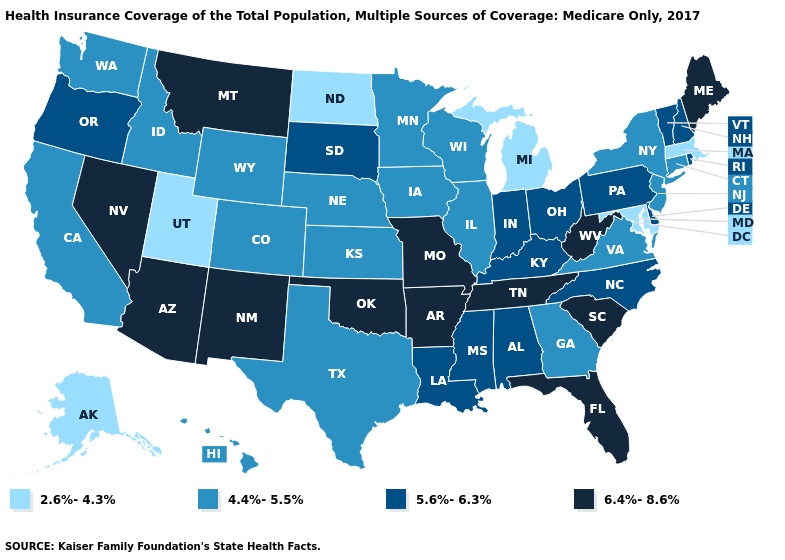What is the value of Arkansas?
Write a very short answer. 6.4%-8.6%. Among the states that border Ohio , which have the highest value?
Keep it brief. West Virginia. Does New York have a higher value than Michigan?
Be succinct. Yes. Which states hav the highest value in the MidWest?
Write a very short answer. Missouri. Among the states that border Florida , which have the lowest value?
Short answer required. Georgia. Name the states that have a value in the range 4.4%-5.5%?
Keep it brief. California, Colorado, Connecticut, Georgia, Hawaii, Idaho, Illinois, Iowa, Kansas, Minnesota, Nebraska, New Jersey, New York, Texas, Virginia, Washington, Wisconsin, Wyoming. Name the states that have a value in the range 6.4%-8.6%?
Be succinct. Arizona, Arkansas, Florida, Maine, Missouri, Montana, Nevada, New Mexico, Oklahoma, South Carolina, Tennessee, West Virginia. How many symbols are there in the legend?
Write a very short answer. 4. What is the value of Nevada?
Give a very brief answer. 6.4%-8.6%. Which states have the lowest value in the MidWest?
Short answer required. Michigan, North Dakota. Does Rhode Island have a lower value than Maine?
Write a very short answer. Yes. Does Mississippi have a lower value than Hawaii?
Quick response, please. No. Name the states that have a value in the range 6.4%-8.6%?
Give a very brief answer. Arizona, Arkansas, Florida, Maine, Missouri, Montana, Nevada, New Mexico, Oklahoma, South Carolina, Tennessee, West Virginia. Does the first symbol in the legend represent the smallest category?
Answer briefly. Yes. Name the states that have a value in the range 5.6%-6.3%?
Be succinct. Alabama, Delaware, Indiana, Kentucky, Louisiana, Mississippi, New Hampshire, North Carolina, Ohio, Oregon, Pennsylvania, Rhode Island, South Dakota, Vermont. 